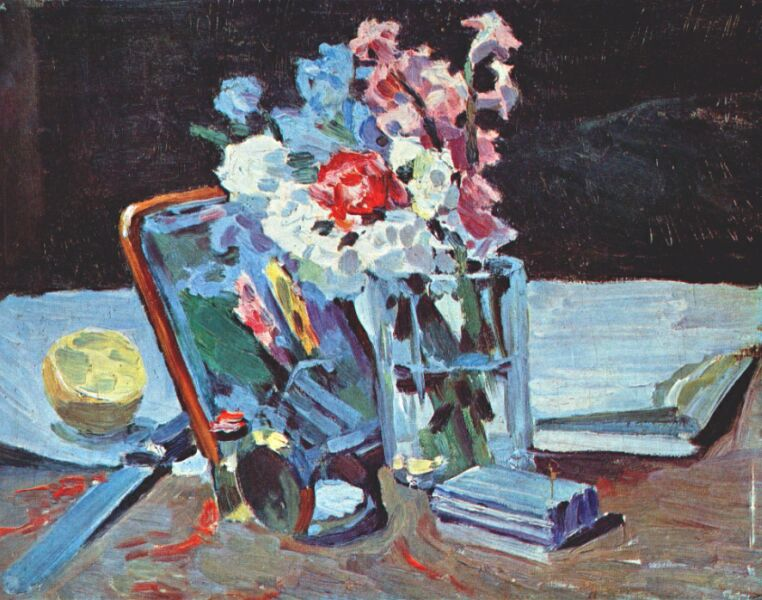Can you elaborate on the elements of the picture provided? Certainly, the image presents a lively still life scene rendered in an impressionist style. At the visual center, we see a glass vase filled with a variety of flowers, including a prominent crimson bloom surrounded by clusters of white and pink blossoms, indicative of possibly peonies. These fresh flowers are juxtaposed against the dark backdrop, enhancing their vividness. Beneath them is a vivid blue book lying askew, suggesting a moment of serene interruption. Adding to the sense of a personal living space, a glass ball, which reflects the surrounding lights, and a striped object that could be a mallet rest beside the books. The reflective surfaces and the play of light and shadow give this composition a sense of depth and texture, inviting the viewer to consider the moment captured here as both deliberate and transient. 